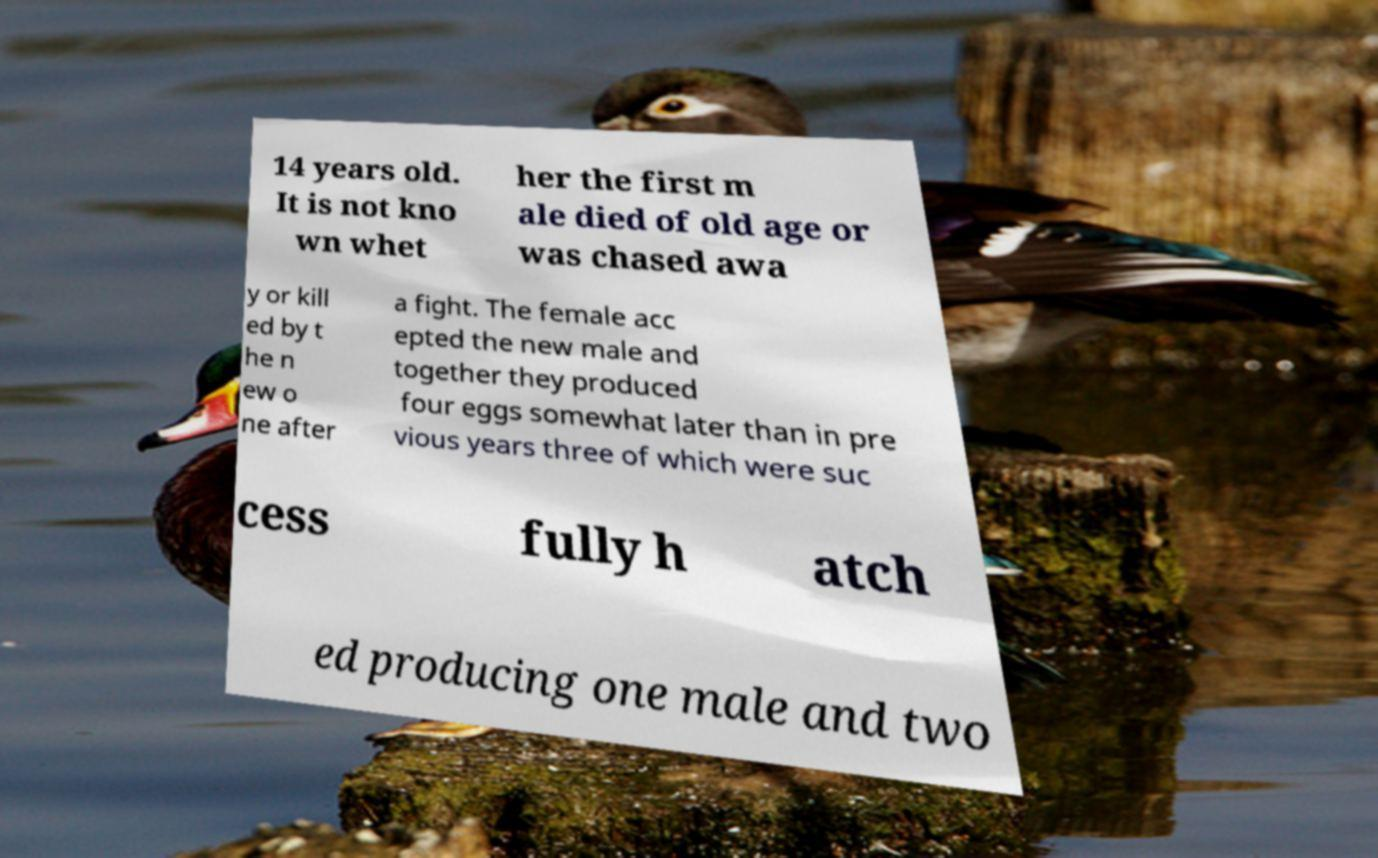There's text embedded in this image that I need extracted. Can you transcribe it verbatim? 14 years old. It is not kno wn whet her the first m ale died of old age or was chased awa y or kill ed by t he n ew o ne after a fight. The female acc epted the new male and together they produced four eggs somewhat later than in pre vious years three of which were suc cess fully h atch ed producing one male and two 